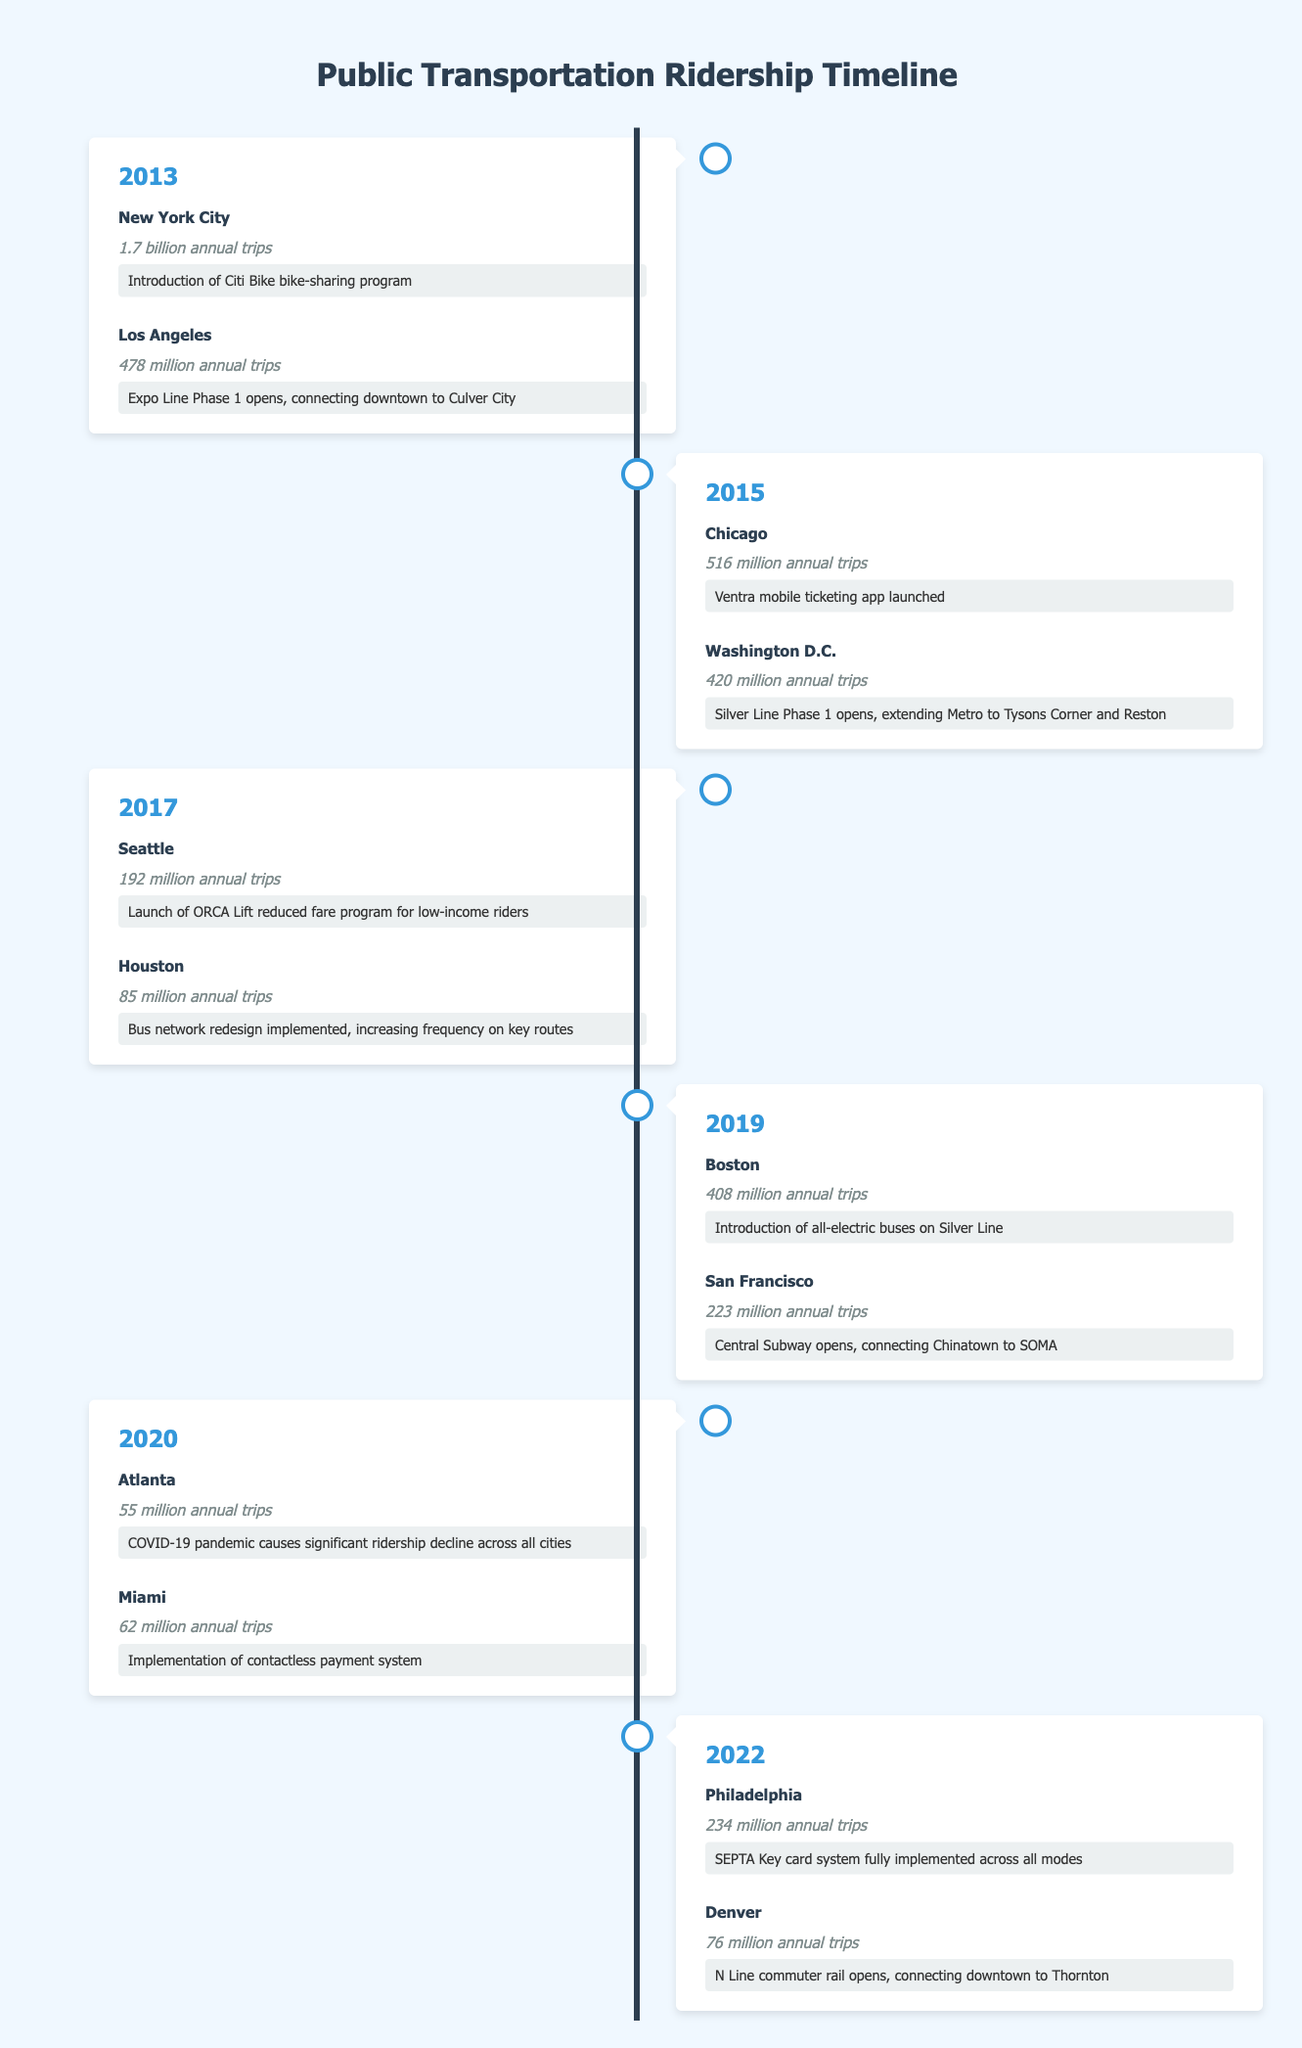What was the total ridership in New York City for the year 2013? In 2013, New York City's ridership was stated as 1.7 billion annual trips.
Answer: 1.7 billion annual trips Which city had the highest ridership in 2015? According to the table, Chicago had 516 million annual trips while Washington D.C. had 420 million, making Chicago the highest that year.
Answer: Chicago Was there a significant decline in ridership in Atlanta during 2020 compared to the previous years? In 2020, Atlanta's ridership was 55 million annual trips, a significant decrease compared to previous years such as 2019 where ridership was not mentioned but was higher than 55 million. Yes, there was a decline.
Answer: Yes What was the average annual ridership for the cities listed in 2019? To find the average, take the sum of Boston’s 408 million and San Francisco’s 223 million which totals 631 million, then divide by 2 giving an average of 315.5 million.
Answer: 315.5 million Did Philadelphia implement a new fare system in 2022? Yes, the note for Philadelphia states that the SEPTA Key card system was fully implemented across all modes, confirming the implementation of a new fare system.
Answer: Yes Which city's public transportation saw a major service addition in 2017? Seattle saw the launch of the ORCA Lift reduced fare program for low-income riders, indicating an addition to their public transportation services.
Answer: Seattle How many million annual trips did Houston record in 2017? Houston's ridership was explicitly listed as 85 million annual trips in 2017.
Answer: 85 million annual trips What was the percentage decrease in ridership for Atlanta from 2019 to 2020? Assuming Atlanta's ridership was significantly higher in 2019, you would first need to establish its 2019 number (not displayed). However, from the 2020 number, the ridership dropped to 55 million. Hence, without the exact 2019 number, it's not possible to compute the exact percentage. Therefore, this question cannot be answered precisely with the data provided.
Answer: Cannot be determined What notable public transportation feature was introduced in 2013 in Los Angeles? In 2013, Los Angeles opened the Expo Line Phase 1, which connects downtown to Culver City, as a new addition to their public transportation system.
Answer: Expo Line Phase 1 